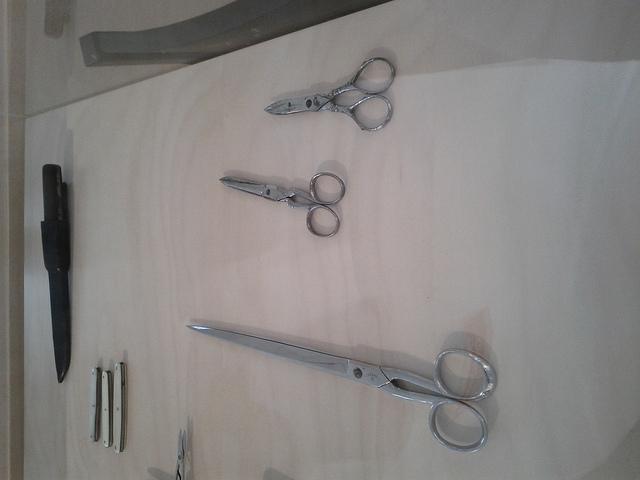How many pairs of scissors?
Give a very brief answer. 3. How many scissors are on the image?
Give a very brief answer. 3. How many scissors are there?
Give a very brief answer. 3. How many motor vehicles have orange paint?
Give a very brief answer. 0. 